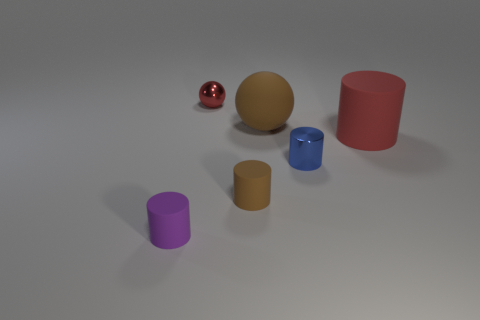The big cylinder has what color?
Make the answer very short. Red. What number of big things are balls or brown spheres?
Offer a very short reply. 1. Is the color of the small metallic thing that is on the right side of the small ball the same as the big matte thing that is in front of the big brown rubber thing?
Your answer should be very brief. No. How many other objects are there of the same color as the metal ball?
Make the answer very short. 1. What is the shape of the red thing that is to the right of the tiny red thing?
Offer a terse response. Cylinder. Are there fewer small red cylinders than tiny blue things?
Keep it short and to the point. Yes. Are the red object behind the red matte cylinder and the red cylinder made of the same material?
Offer a very short reply. No. Is there anything else that has the same size as the red rubber cylinder?
Offer a terse response. Yes. Are there any small red spheres in front of the small blue cylinder?
Offer a terse response. No. The small matte thing that is to the left of the brown thing in front of the big thing that is left of the small blue object is what color?
Your answer should be very brief. Purple. 